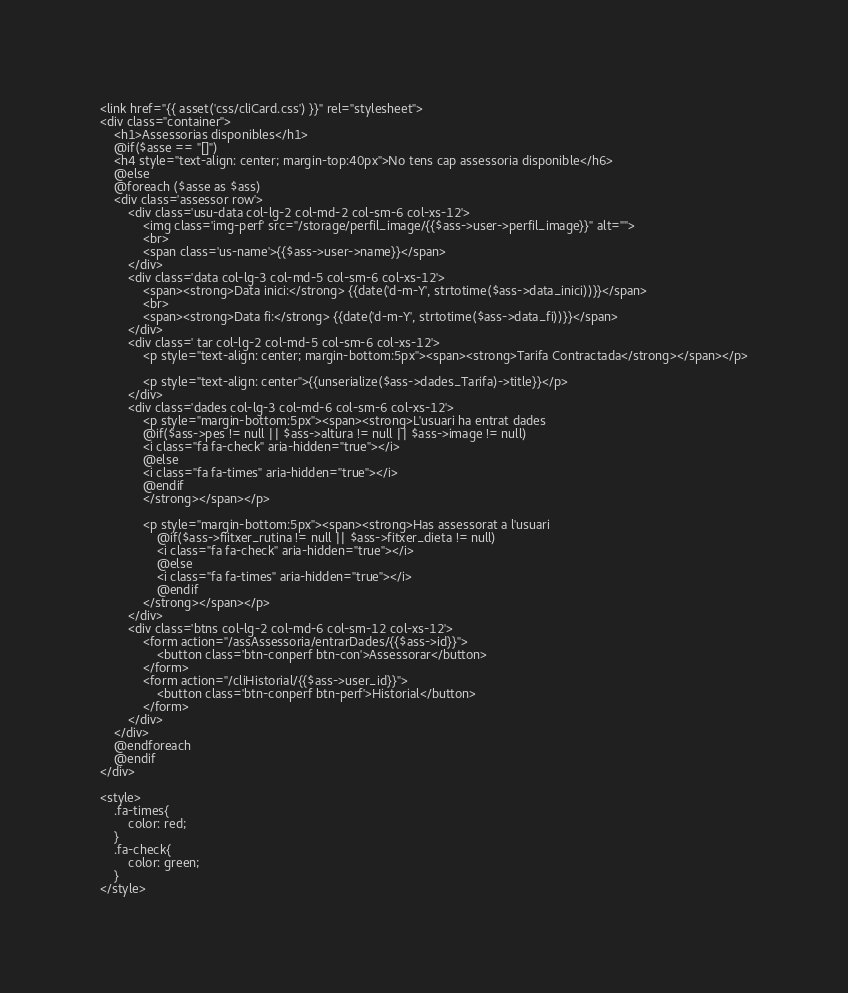Convert code to text. <code><loc_0><loc_0><loc_500><loc_500><_PHP_><link href="{{ asset('css/cliCard.css') }}" rel="stylesheet">
<div class="container">
    <h1>Assessorias disponibles</h1>
    @if($asse == "[]")
    <h4 style="text-align: center; margin-top:40px">No tens cap assessoria disponible</h6>
    @else
    @foreach ($asse as $ass)
    <div class='assessor row'>
        <div class='usu-data col-lg-2 col-md-2 col-sm-6 col-xs-12'>
            <img class='img-perf' src="/storage/perfil_image/{{$ass->user->perfil_image}}" alt="">
            <br>
            <span class='us-name'>{{$ass->user->name}}</span>
        </div>
        <div class='data col-lg-3 col-md-5 col-sm-6 col-xs-12'>
            <span><strong>Data inici:</strong> {{date('d-m-Y', strtotime($ass->data_inici))}}</span>
            <br>
            <span><strong>Data fi:</strong> {{date('d-m-Y', strtotime($ass->data_fi))}}</span>
        </div>
        <div class=' tar col-lg-2 col-md-5 col-sm-6 col-xs-12'>
            <p style="text-align: center; margin-bottom:5px"><span><strong>Tarifa Contractada</strong></span></p>
            
            <p style="text-align: center">{{unserialize($ass->dades_Tarifa)->title}}</p>
        </div>
        <div class='dades col-lg-3 col-md-6 col-sm-6 col-xs-12'>
            <p style="margin-bottom:5px"><span><strong>L'usuari ha entrat dades
            @if($ass->pes != null || $ass->altura != null || $ass->image != null)    
            <i class="fa fa-check" aria-hidden="true"></i>
            @else
            <i class="fa fa-times" aria-hidden="true"></i>
            @endif
            </strong></span></p>
            
            <p style="margin-bottom:5px"><span><strong>Has assessorat a l'usuari
                @if($ass->fiitxer_rutina != null || $ass->fitxer_dieta != null)    
                <i class="fa fa-check" aria-hidden="true"></i>
                @else
                <i class="fa fa-times" aria-hidden="true"></i>
                @endif    
            </strong></span></p>
        </div>
        <div class='btns col-lg-2 col-md-6 col-sm-12 col-xs-12'>
            <form action="/assAssessoria/entrarDades/{{$ass->id}}">
                <button class='btn-conperf btn-con'>Assessorar</button>
            </form>
            <form action="/cliHistorial/{{$ass->user_id}}">
                <button class='btn-conperf btn-perf'>Historial</button>
            </form>
        </div>
    </div>           
    @endforeach
    @endif
</div>

<style>
    .fa-times{
        color: red;
    }
    .fa-check{
        color: green;
    }
</style></code> 